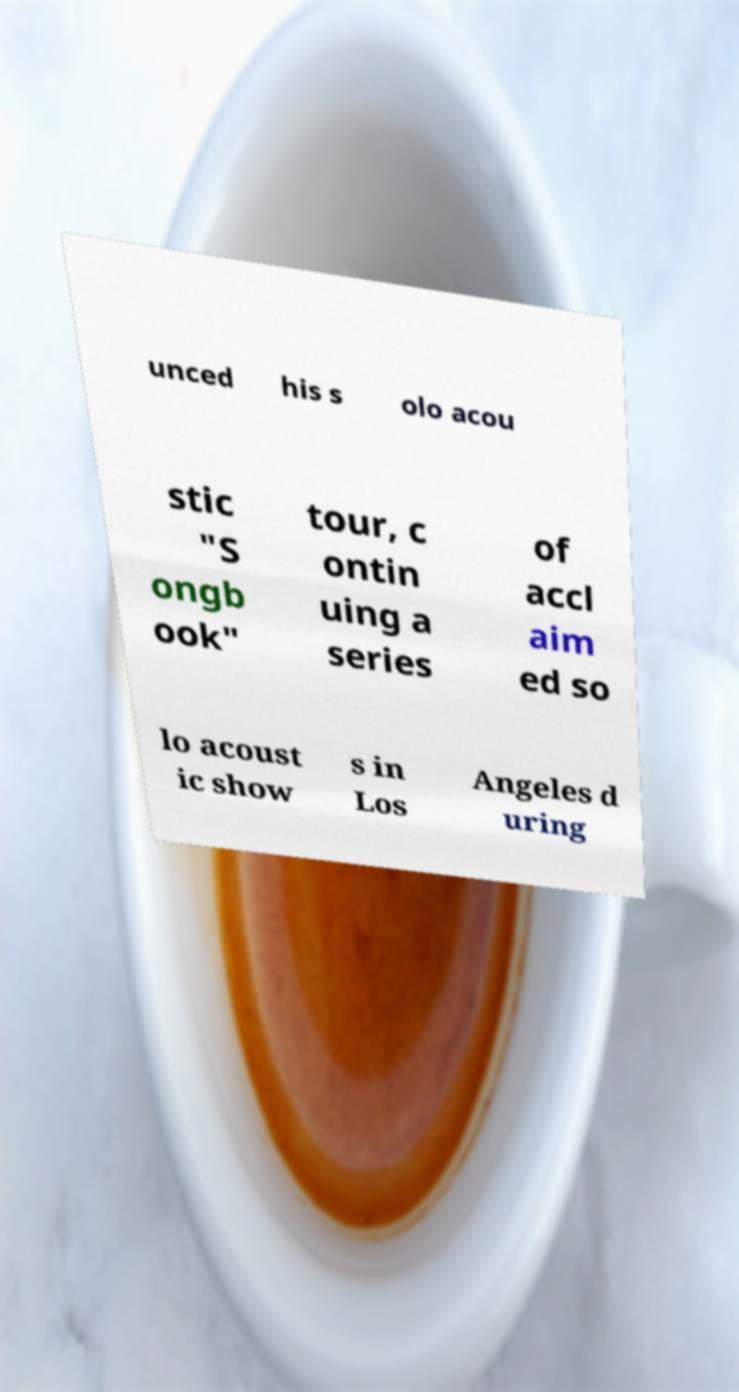Can you read and provide the text displayed in the image?This photo seems to have some interesting text. Can you extract and type it out for me? unced his s olo acou stic "S ongb ook" tour, c ontin uing a series of accl aim ed so lo acoust ic show s in Los Angeles d uring 